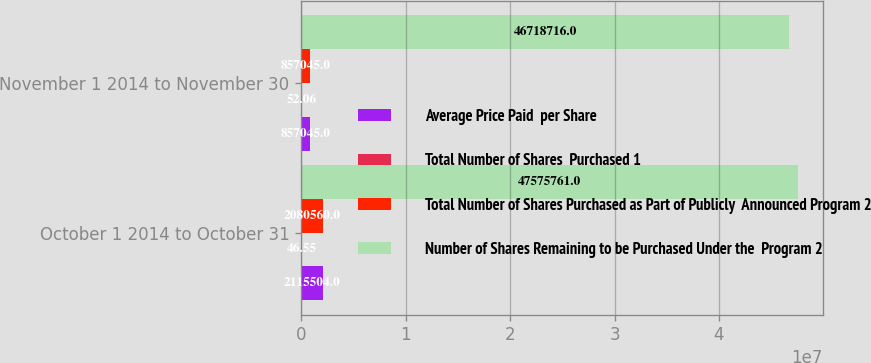<chart> <loc_0><loc_0><loc_500><loc_500><stacked_bar_chart><ecel><fcel>October 1 2014 to October 31<fcel>November 1 2014 to November 30<nl><fcel>Average Price Paid  per Share<fcel>2.1155e+06<fcel>857045<nl><fcel>Total Number of Shares  Purchased 1<fcel>46.55<fcel>52.06<nl><fcel>Total Number of Shares Purchased as Part of Publicly  Announced Program 2<fcel>2.08056e+06<fcel>857045<nl><fcel>Number of Shares Remaining to be Purchased Under the  Program 2<fcel>4.75758e+07<fcel>4.67187e+07<nl></chart> 